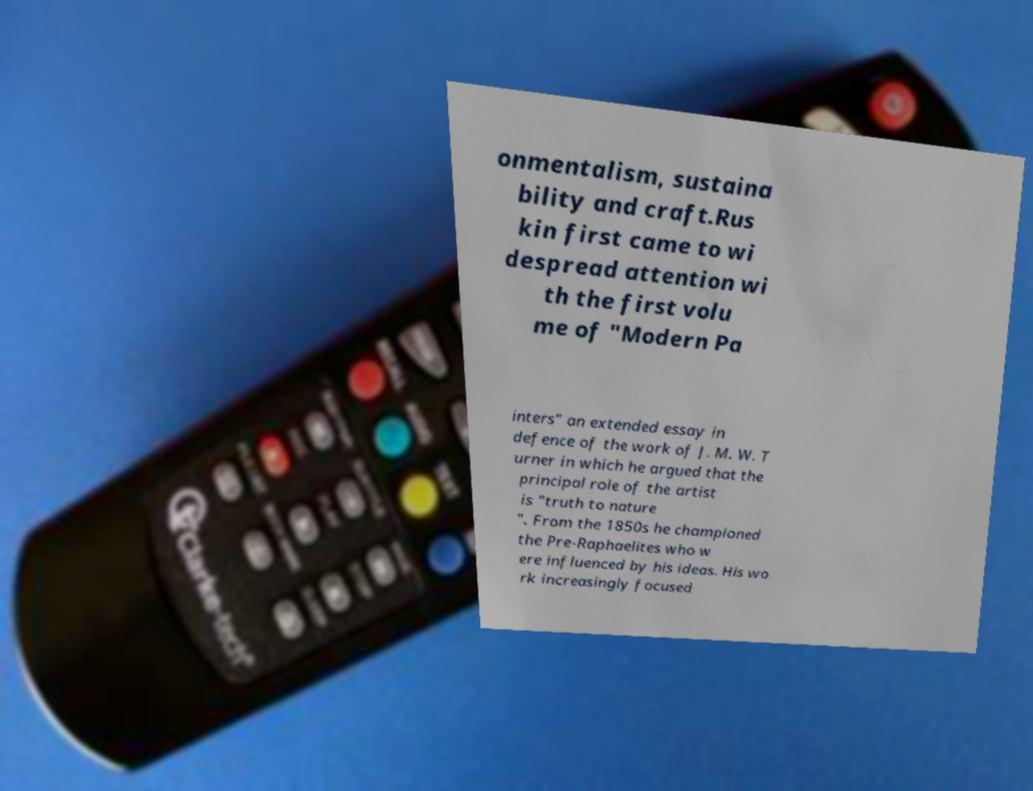Please identify and transcribe the text found in this image. onmentalism, sustaina bility and craft.Rus kin first came to wi despread attention wi th the first volu me of "Modern Pa inters" an extended essay in defence of the work of J. M. W. T urner in which he argued that the principal role of the artist is "truth to nature ". From the 1850s he championed the Pre-Raphaelites who w ere influenced by his ideas. His wo rk increasingly focused 